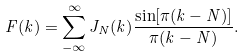<formula> <loc_0><loc_0><loc_500><loc_500>F ( k ) = \sum _ { - \infty } ^ { \infty } J _ { N } ( k ) \frac { \sin [ \pi ( k - N ) ] } { \pi ( k - N ) } .</formula> 